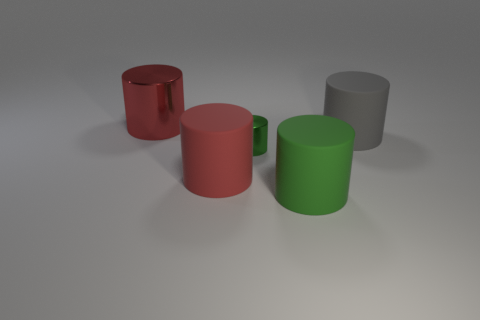Subtract all large red metallic cylinders. How many cylinders are left? 4 Add 4 red metal cylinders. How many objects exist? 9 Subtract all red cylinders. How many cylinders are left? 3 Subtract 5 cylinders. How many cylinders are left? 0 Add 3 green matte cylinders. How many green matte cylinders are left? 4 Add 4 large gray matte objects. How many large gray matte objects exist? 5 Subtract 0 cyan blocks. How many objects are left? 5 Subtract all yellow cylinders. Subtract all green cubes. How many cylinders are left? 5 Subtract all yellow balls. How many green cylinders are left? 2 Subtract all big red objects. Subtract all big gray matte things. How many objects are left? 2 